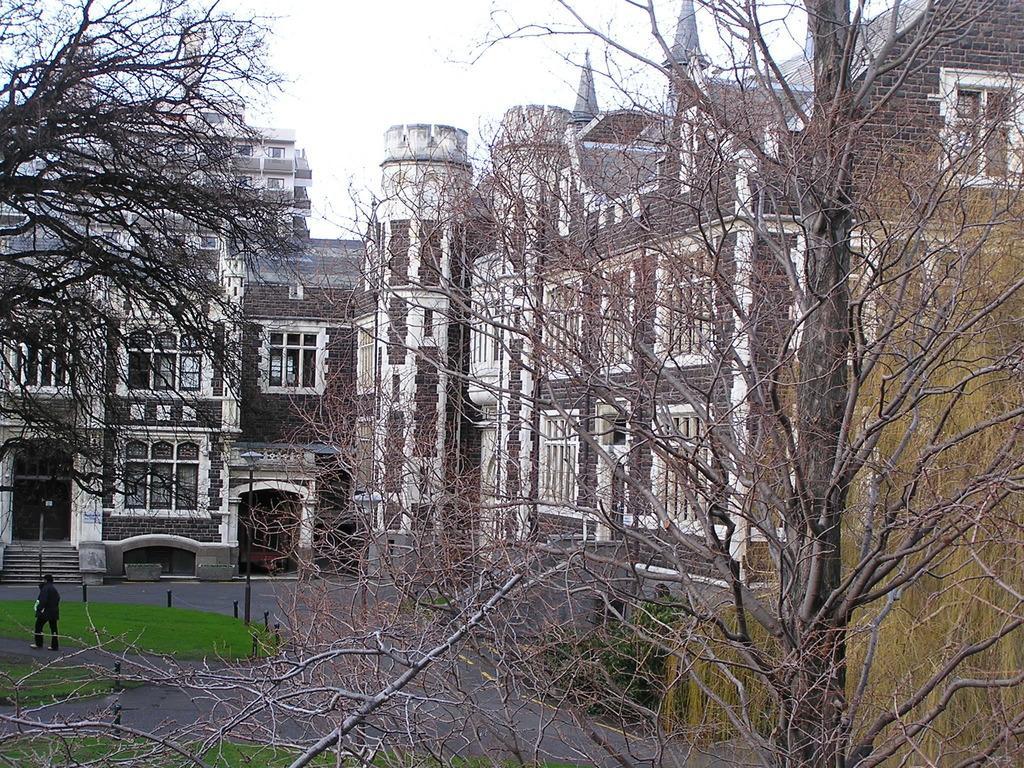In one or two sentences, can you explain what this image depicts? In this image we can see trees. On the left side there is a person walking on the road. In the back there are buildings with windows. In front of the building there are steps. In the background there is sky. 